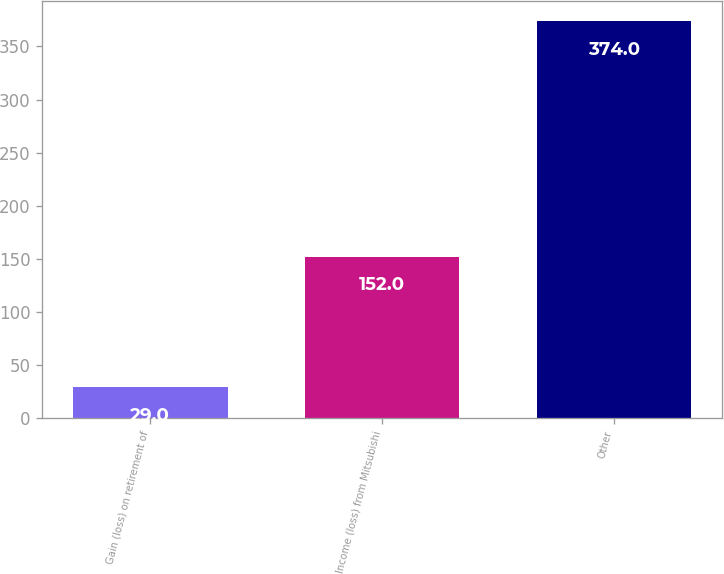Convert chart to OTSL. <chart><loc_0><loc_0><loc_500><loc_500><bar_chart><fcel>Gain (loss) on retirement of<fcel>Income (loss) from Mitsubishi<fcel>Other<nl><fcel>29<fcel>152<fcel>374<nl></chart> 